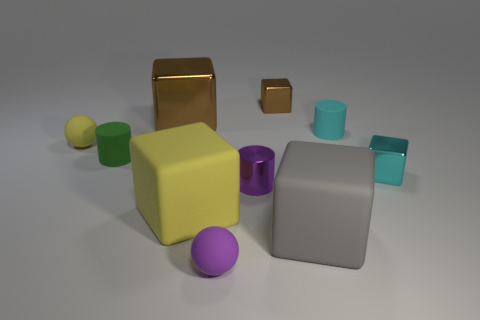What size is the green object that is the same shape as the tiny cyan rubber object?
Provide a short and direct response. Small. There is a ball that is the same color as the tiny metal cylinder; what is its material?
Offer a terse response. Rubber. There is a metallic cylinder; is its color the same as the small ball that is on the right side of the large brown shiny block?
Offer a terse response. Yes. Is the number of big brown blocks greater than the number of big green balls?
Your response must be concise. Yes. What number of blocks are either purple objects or small yellow objects?
Keep it short and to the point. 0. What color is the shiny cylinder?
Ensure brevity in your answer.  Purple. Does the yellow thing that is in front of the tiny yellow matte ball have the same size as the yellow thing behind the purple cylinder?
Keep it short and to the point. No. Are there fewer cyan metal things than rubber cylinders?
Provide a succinct answer. Yes. There is a small cyan metallic object; what number of yellow cubes are behind it?
Give a very brief answer. 0. What is the big yellow thing made of?
Keep it short and to the point. Rubber. 